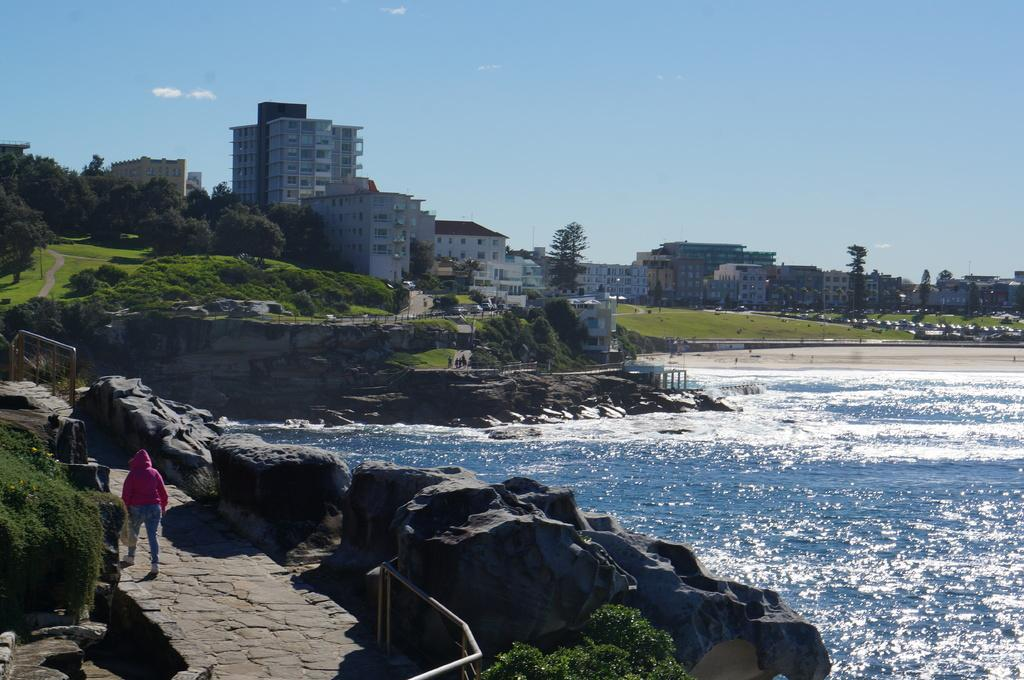How many people are in the image? There is one person in the image. What type of natural elements can be seen in the image? Trees, plants, grass, rocks, and water are visible in the image. What type of man-made structures are present in the image? There are buildings in the image. What is visible at the top of the image? The sky is visible at the top of the image. What type of soup is being served in the picture? There is no soup present in the image; it features a person, natural elements, buildings, and the sky. What is the end result of the person's actions in the image? The image does not depict any actions being performed by the person, so it is not possible to determine the end result of their actions. 